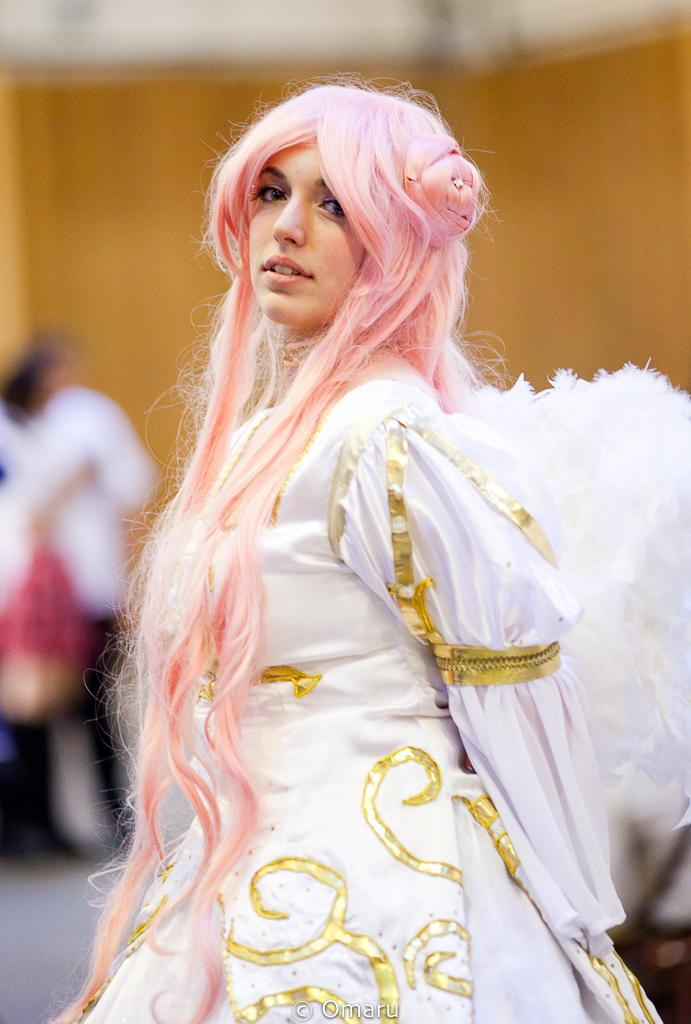Who is the main subject in the image? There is a woman in the image. What is the woman wearing? The woman is wearing a white gown. What color is the woman's hair? The woman's hair is pink. What is the woman doing with her mouth? The woman's mouth is open. How many brothers does the woman have in the image? There is no information about the woman's brothers in the image. What type of ornament is hanging from the woman's ear in the image? There is no ornament visible on the woman's ear in the image. 